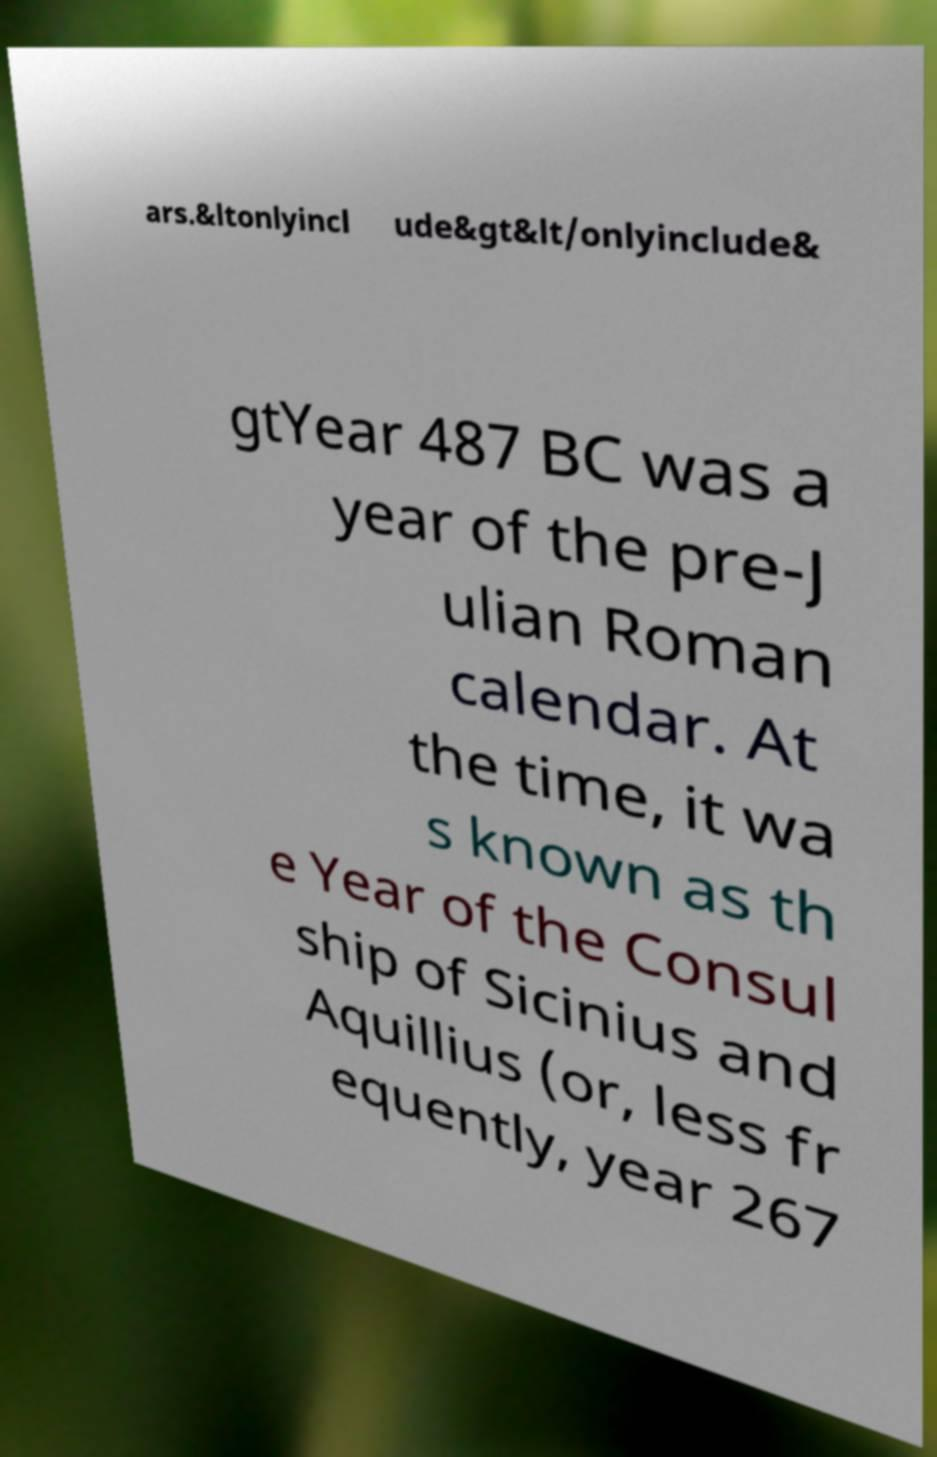Could you extract and type out the text from this image? ars.&ltonlyincl ude&gt&lt/onlyinclude& gtYear 487 BC was a year of the pre-J ulian Roman calendar. At the time, it wa s known as th e Year of the Consul ship of Sicinius and Aquillius (or, less fr equently, year 267 